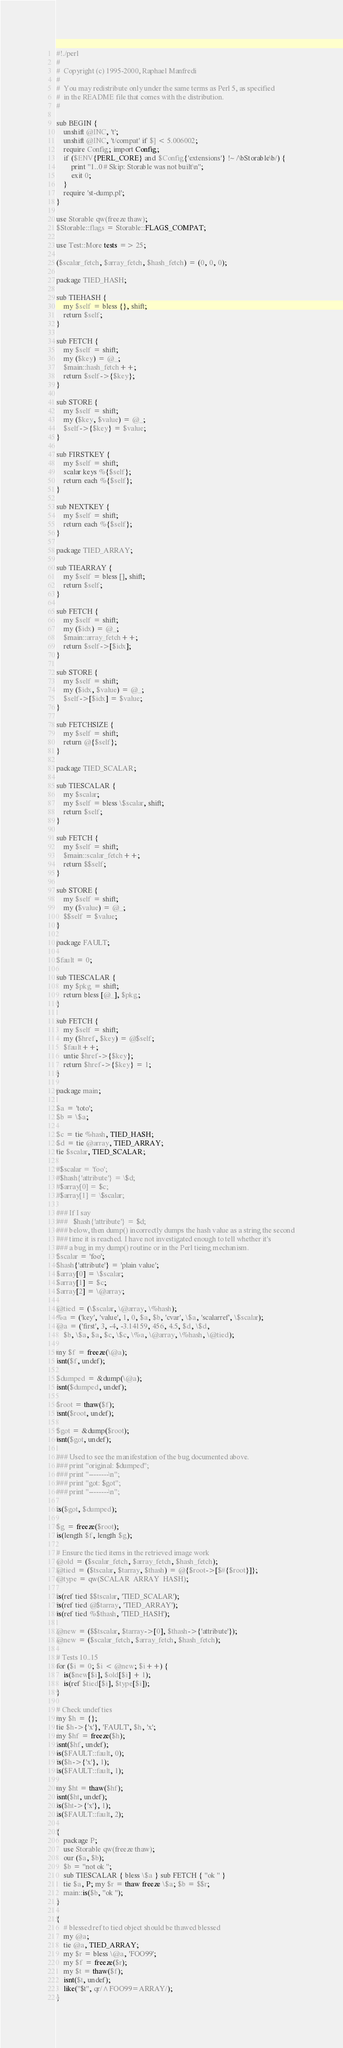Convert code to text. <code><loc_0><loc_0><loc_500><loc_500><_Perl_>#!./perl
#
#  Copyright (c) 1995-2000, Raphael Manfredi
#  
#  You may redistribute only under the same terms as Perl 5, as specified
#  in the README file that comes with the distribution.
#

sub BEGIN {
    unshift @INC, 't';
    unshift @INC, 't/compat' if $] < 5.006002;
    require Config; import Config;
    if ($ENV{PERL_CORE} and $Config{'extensions'} !~ /\bStorable\b/) {
        print "1..0 # Skip: Storable was not built\n";
        exit 0;
    }
    require 'st-dump.pl';
}

use Storable qw(freeze thaw);
$Storable::flags = Storable::FLAGS_COMPAT;

use Test::More tests => 25;

($scalar_fetch, $array_fetch, $hash_fetch) = (0, 0, 0);

package TIED_HASH;

sub TIEHASH {
	my $self = bless {}, shift;
	return $self;
}

sub FETCH {
	my $self = shift;
	my ($key) = @_;
	$main::hash_fetch++;
	return $self->{$key};
}

sub STORE {
	my $self = shift;
	my ($key, $value) = @_;
	$self->{$key} = $value;
}

sub FIRSTKEY {
	my $self = shift;
	scalar keys %{$self};
	return each %{$self};
}

sub NEXTKEY {
	my $self = shift;
	return each %{$self};
}

package TIED_ARRAY;

sub TIEARRAY {
	my $self = bless [], shift;
	return $self;
}

sub FETCH {
	my $self = shift;
	my ($idx) = @_;
	$main::array_fetch++;
	return $self->[$idx];
}

sub STORE {
	my $self = shift;
	my ($idx, $value) = @_;
	$self->[$idx] = $value;
}

sub FETCHSIZE {
	my $self = shift;
	return @{$self};
}

package TIED_SCALAR;

sub TIESCALAR {
	my $scalar;
	my $self = bless \$scalar, shift;
	return $self;
}

sub FETCH {
	my $self = shift;
	$main::scalar_fetch++;
	return $$self;
}

sub STORE {
	my $self = shift;
	my ($value) = @_;
	$$self = $value;
}

package FAULT;

$fault = 0;

sub TIESCALAR {
	my $pkg = shift;
	return bless [@_], $pkg;
}

sub FETCH {
	my $self = shift;
	my ($href, $key) = @$self;
	$fault++;
	untie $href->{$key};
	return $href->{$key} = 1;
}

package main;

$a = 'toto';
$b = \$a;

$c = tie %hash, TIED_HASH;
$d = tie @array, TIED_ARRAY;
tie $scalar, TIED_SCALAR;

#$scalar = 'foo';
#$hash{'attribute'} = \$d;
#$array[0] = $c;
#$array[1] = \$scalar;

### If I say
###   $hash{'attribute'} = $d;
### below, then dump() incorrectly dumps the hash value as a string the second
### time it is reached. I have not investigated enough to tell whether it's
### a bug in my dump() routine or in the Perl tieing mechanism.
$scalar = 'foo';
$hash{'attribute'} = 'plain value';
$array[0] = \$scalar;
$array[1] = $c;
$array[2] = \@array;

@tied = (\$scalar, \@array, \%hash);
%a = ('key', 'value', 1, 0, $a, $b, 'cvar', \$a, 'scalarref', \$scalar);
@a = ('first', 3, -4, -3.14159, 456, 4.5, $d, \$d,
	$b, \$a, $a, $c, \$c, \%a, \@array, \%hash, \@tied);

my $f = freeze(\@a);
isnt($f, undef);

$dumped = &dump(\@a);
isnt($dumped, undef);

$root = thaw($f);
isnt($root, undef);

$got = &dump($root);
isnt($got, undef);

### Used to see the manifestation of the bug documented above.
### print "original: $dumped";
### print "--------\n";
### print "got: $got";
### print "--------\n";

is($got, $dumped);

$g = freeze($root);
is(length $f, length $g);

# Ensure the tied items in the retrieved image work
@old = ($scalar_fetch, $array_fetch, $hash_fetch);
@tied = ($tscalar, $tarray, $thash) = @{$root->[$#{$root}]};
@type = qw(SCALAR  ARRAY  HASH);

is(ref tied $$tscalar, 'TIED_SCALAR');
is(ref tied @$tarray, 'TIED_ARRAY');
is(ref tied %$thash, 'TIED_HASH');

@new = ($$tscalar, $tarray->[0], $thash->{'attribute'});
@new = ($scalar_fetch, $array_fetch, $hash_fetch);

# Tests 10..15
for ($i = 0; $i < @new; $i++) {
	is($new[$i], $old[$i] + 1);
	is(ref $tied[$i], $type[$i]);
}

# Check undef ties
my $h = {};
tie $h->{'x'}, 'FAULT', $h, 'x';
my $hf = freeze($h);
isnt($hf, undef);
is($FAULT::fault, 0);
is($h->{'x'}, 1);
is($FAULT::fault, 1);

my $ht = thaw($hf);
isnt($ht, undef);
is($ht->{'x'}, 1);
is($FAULT::fault, 2);

{
    package P;
    use Storable qw(freeze thaw);
    our ($a, $b);
    $b = "not ok ";
    sub TIESCALAR { bless \$a } sub FETCH { "ok " }
    tie $a, P; my $r = thaw freeze \$a; $b = $$r;
    main::is($b, "ok ");
}

{
    # blessed ref to tied object should be thawed blessed
    my @a;
    tie @a, TIED_ARRAY;
    my $r = bless \@a, 'FOO99';
    my $f = freeze($r);
    my $t = thaw($f);
    isnt($t, undef);
    like("$t", qr/^FOO99=ARRAY/);
}
</code> 